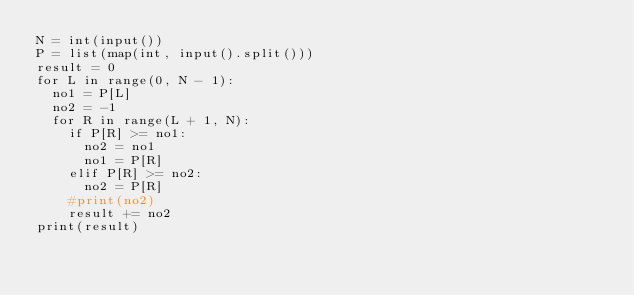<code> <loc_0><loc_0><loc_500><loc_500><_Python_>N = int(input())
P = list(map(int, input().split()))
result = 0
for L in range(0, N - 1):
  no1 = P[L]
  no2 = -1
  for R in range(L + 1, N):
    if P[R] >= no1:
      no2 = no1
      no1 = P[R]
    elif P[R] >= no2:
      no2 = P[R]
    #print(no2)
    result += no2
print(result)
</code> 